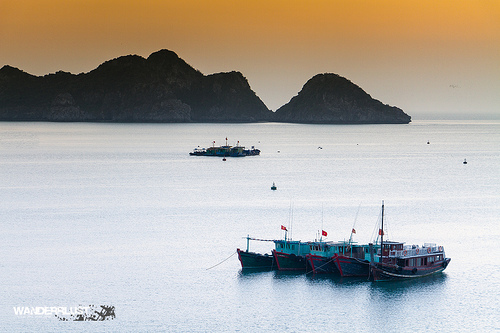<image>
Is the sky behind the mountain? Yes. From this viewpoint, the sky is positioned behind the mountain, with the mountain partially or fully occluding the sky. Is there a boat in the water? Yes. The boat is contained within or inside the water, showing a containment relationship. 